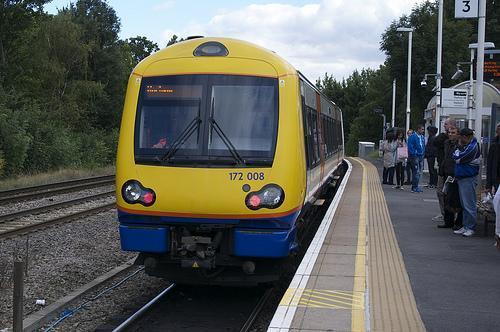How many trains are in the picture?
Give a very brief answer. 1. 